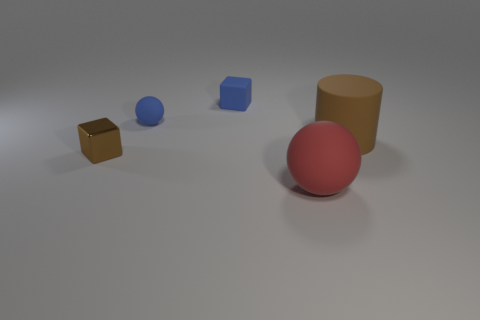Are there an equal number of blue rubber cubes that are to the right of the matte cylinder and tiny spheres that are behind the tiny blue rubber ball?
Offer a terse response. Yes. What number of other things are there of the same material as the small blue block
Make the answer very short. 3. What number of matte things are either tiny cyan objects or cylinders?
Make the answer very short. 1. There is a large object behind the red matte object; is it the same shape as the red rubber object?
Provide a succinct answer. No. Is the number of brown metallic blocks that are behind the matte cylinder greater than the number of blue matte blocks?
Offer a terse response. No. What number of objects are in front of the rubber cube and left of the red matte sphere?
Offer a terse response. 2. There is a block in front of the cube that is to the right of the tiny brown cube; what color is it?
Your response must be concise. Brown. How many rubber cylinders are the same color as the tiny matte ball?
Provide a short and direct response. 0. Is the color of the tiny sphere the same as the thing right of the red rubber ball?
Provide a succinct answer. No. Are there fewer small rubber objects than metal blocks?
Provide a short and direct response. No. 